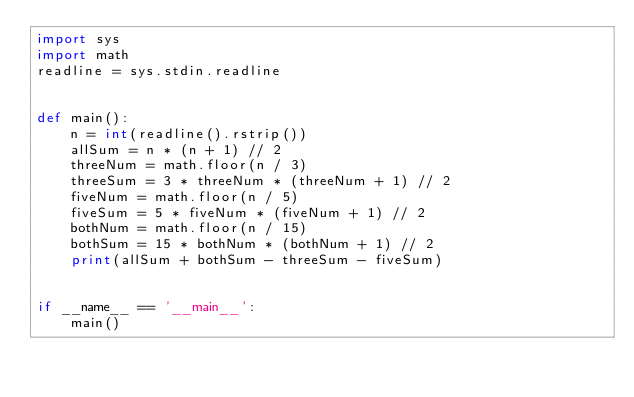<code> <loc_0><loc_0><loc_500><loc_500><_Python_>import sys
import math
readline = sys.stdin.readline


def main():
    n = int(readline().rstrip())
    allSum = n * (n + 1) // 2
    threeNum = math.floor(n / 3)
    threeSum = 3 * threeNum * (threeNum + 1) // 2
    fiveNum = math.floor(n / 5)
    fiveSum = 5 * fiveNum * (fiveNum + 1) // 2
    bothNum = math.floor(n / 15)
    bothSum = 15 * bothNum * (bothNum + 1) // 2
    print(allSum + bothSum - threeSum - fiveSum)


if __name__ == '__main__':
    main()
</code> 